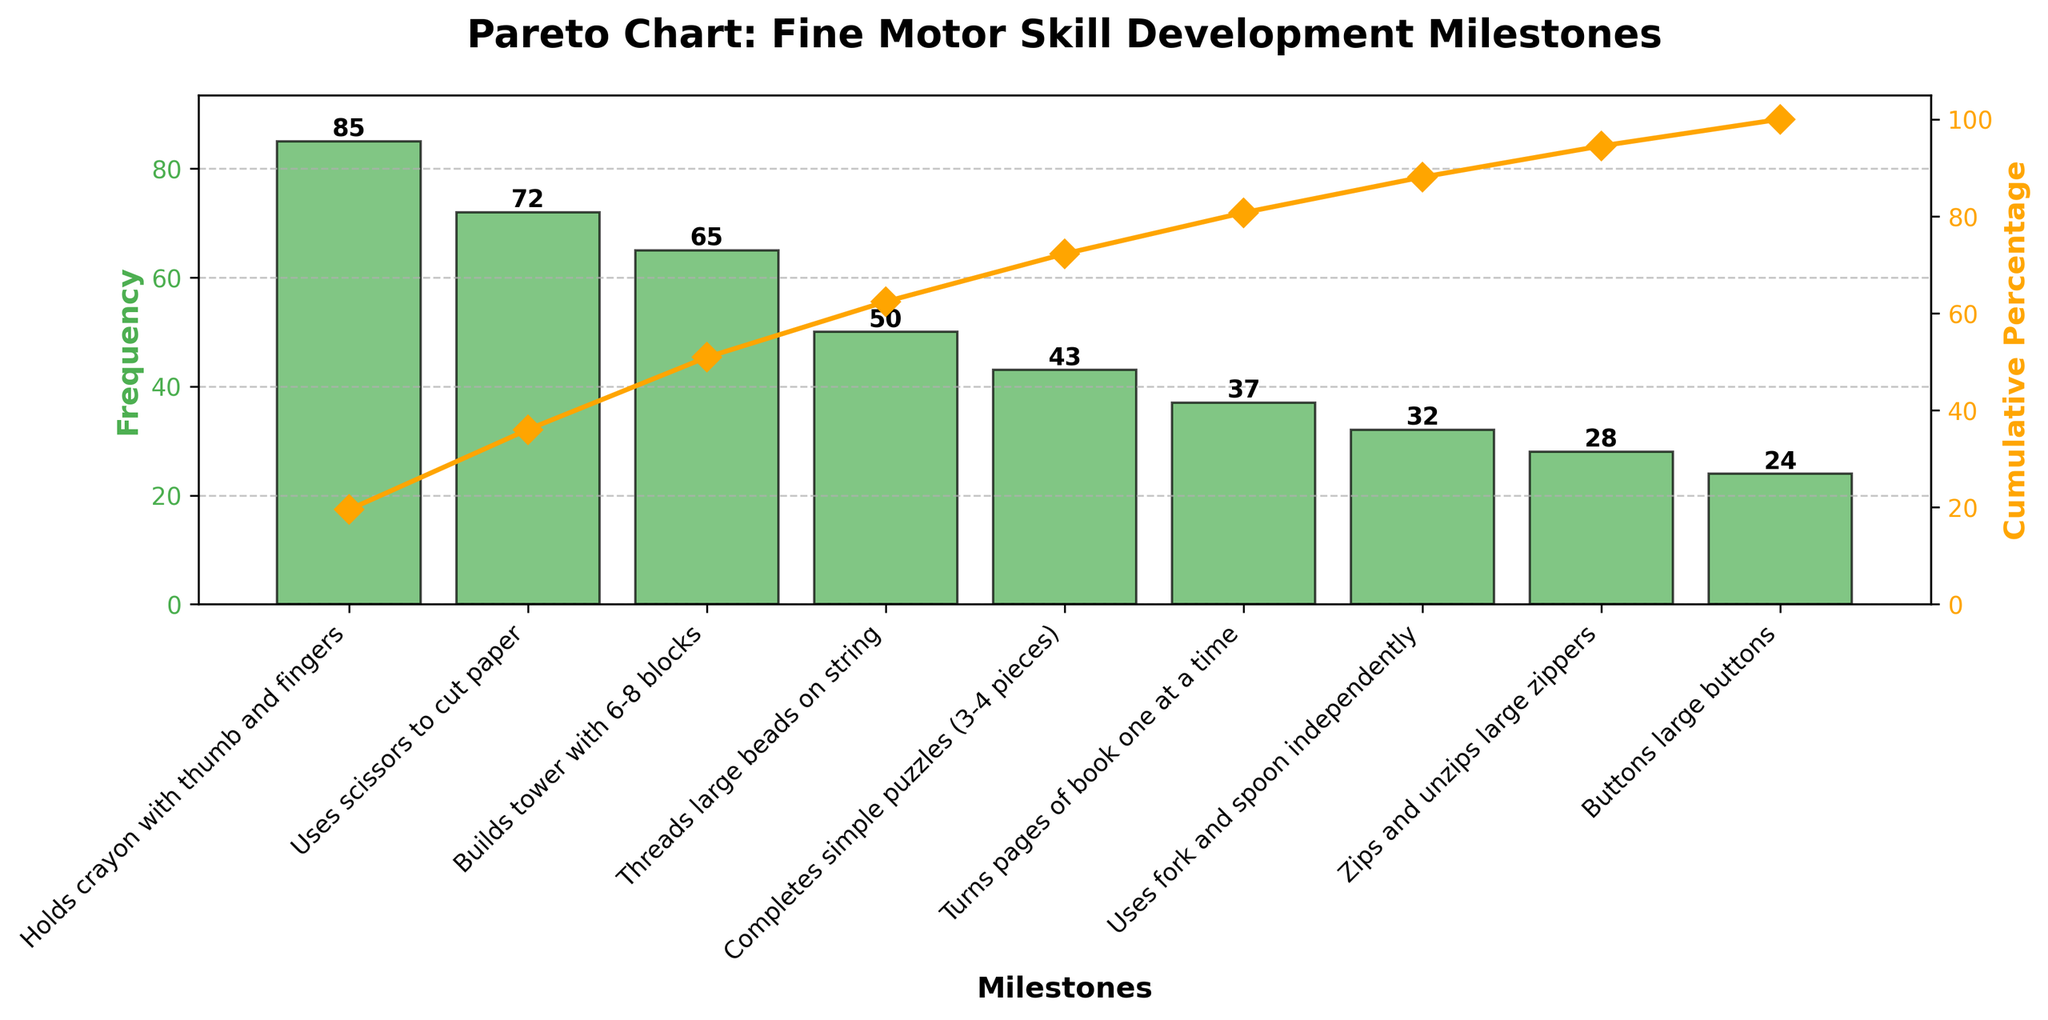What's the title of the figure? The title is located at the top of the figure, indicating the main subject of the chart.
Answer: Pareto Chart: Fine Motor Skill Development Milestones What is the milestone with the highest frequency? By looking at the lengths of the bars, the tallest bar represents the milestone with the highest frequency.
Answer: Holds crayon with thumb and fingers What is the cumulative percentage for the milestone "Threads large beads on string"? Find the line plot point corresponding to "Threads large beads on string" and look at the y-axis value on the right.
Answer: 75% How many milestones have a frequency greater than 30? Count the number of bars with heights greater than 30 on the left y-axis.
Answer: 6 Which milestone has a higher frequency: "Builds tower with 6-8 blocks" or "Completes simple puzzles (3-4 pieces)"? Compare the bar heights for the two milestones.
Answer: Builds tower with 6-8 blocks What is the frequency of "Uses fork and spoon independently"? Identify the bar representing this milestone and read the value at the top of the bar or along the left y-axis.
Answer: 32 What is the total frequency of the first three milestones combined? Add the frequencies of the first three milestones: 85 (Holds crayon with thumb and fingers) + 72 (Uses scissors to cut paper) + 65 (Builds tower with 6-8 blocks).
Answer: 222 At which milestone does the cumulative percentage exceed 50%? Check the line plot and find the milestone at which the cumulative percentage crosses the 50% mark on the right y-axis.
Answer: Threads large beads on string Is the frequency of "Turns pages of book one at a time" closer to 20 or 40? Compare the bar height for this milestone with the approximate extended lines from 20 and 40 on the left y-axis.
Answer: Closer to 40 What is the difference in frequency between "Zips and unzips large zippers" and "Buttons large buttons"? Subtract the frequency of "Buttons large buttons" from "Zips and unzips large zippers" (28 - 24).
Answer: 4 